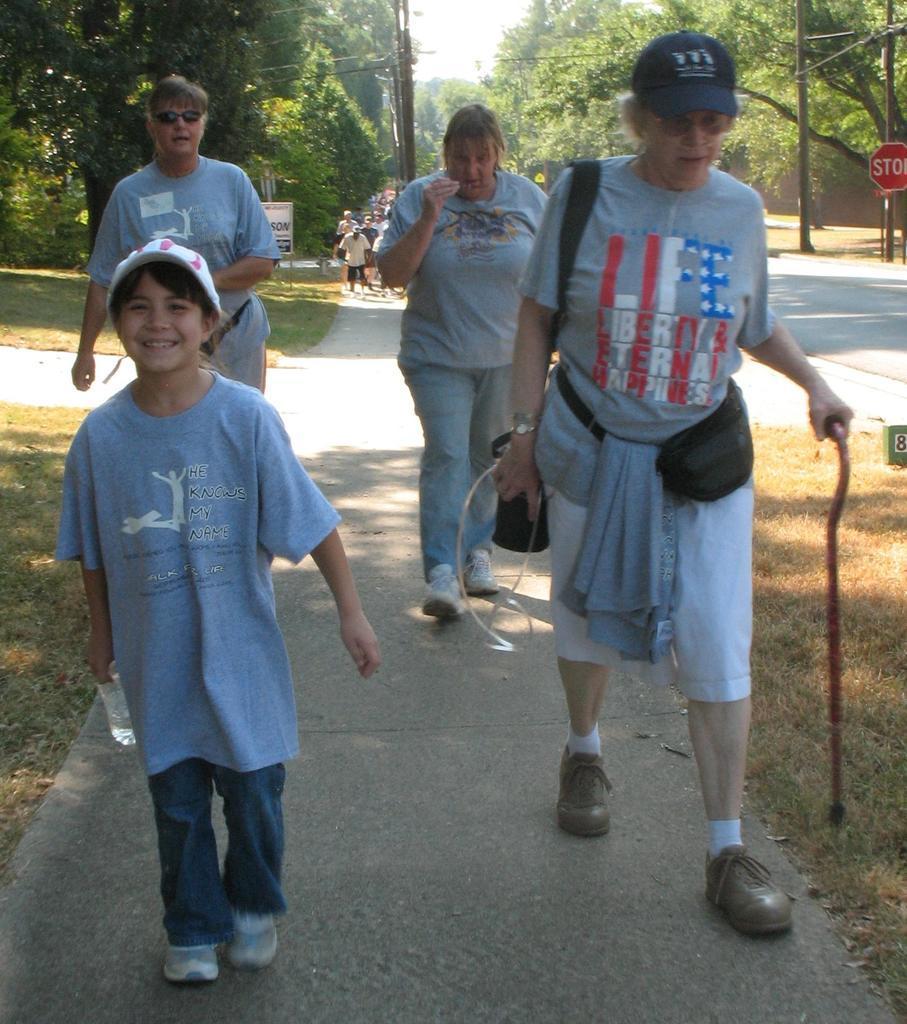Please provide a concise description of this image. This picture is taken from the outside of the city. In this image, in the middle, we can see four people are walking on the road. In the background, we can see a group of people, trees, plants, electric pole, electric wires. At the top, we can see a sky, at the bottom, we can see a road and a grass. 